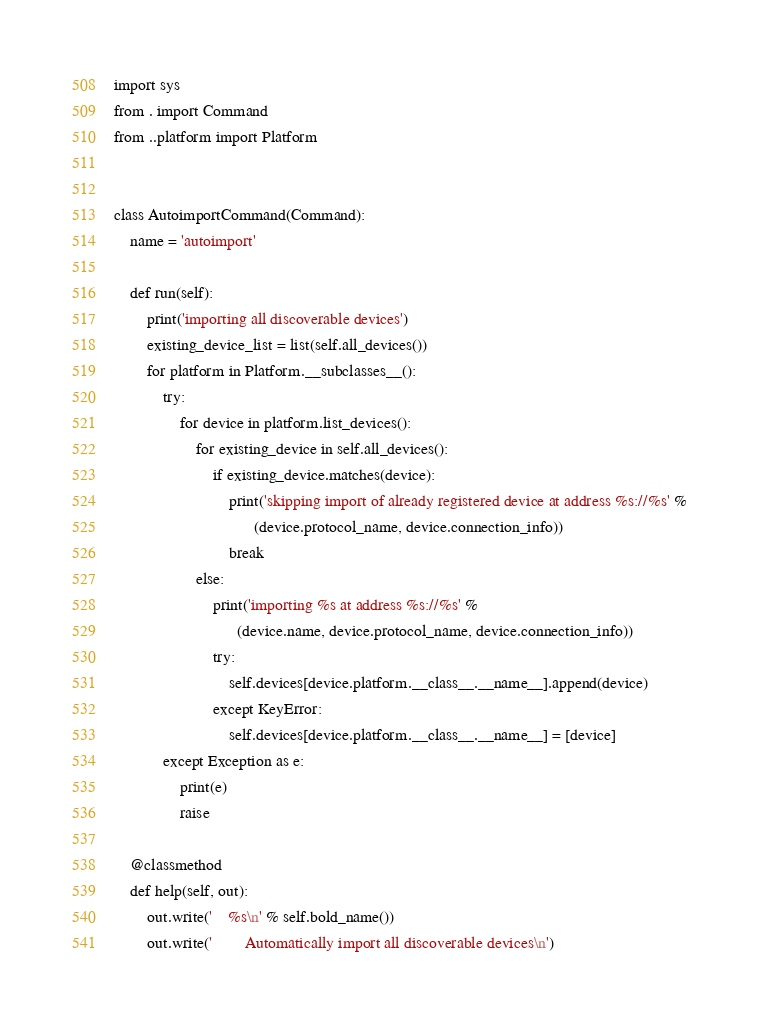Convert code to text. <code><loc_0><loc_0><loc_500><loc_500><_Python_>import sys
from . import Command
from ..platform import Platform


class AutoimportCommand(Command):
    name = 'autoimport'

    def run(self):
        print('importing all discoverable devices')
        existing_device_list = list(self.all_devices())
        for platform in Platform.__subclasses__():
            try:
                for device in platform.list_devices():
                    for existing_device in self.all_devices():
                        if existing_device.matches(device):
                            print('skipping import of already registered device at address %s://%s' %
                                  (device.protocol_name, device.connection_info))
                            break
                    else:
                        print('importing %s at address %s://%s' %
                              (device.name, device.protocol_name, device.connection_info))
                        try:
                            self.devices[device.platform.__class__.__name__].append(device)
                        except KeyError:
                            self.devices[device.platform.__class__.__name__] = [device]
            except Exception as e:
                print(e)
                raise

    @classmethod
    def help(self, out):
        out.write('    %s\n' % self.bold_name())
        out.write('        Automatically import all discoverable devices\n')
</code> 